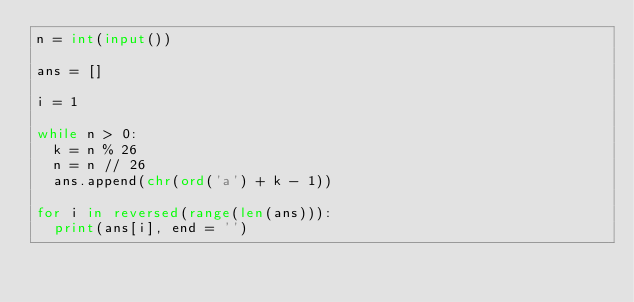Convert code to text. <code><loc_0><loc_0><loc_500><loc_500><_Python_>n = int(input())

ans = []

i = 1

while n > 0:
  k = n % 26
  n = n // 26
  ans.append(chr(ord('a') + k - 1))

for i in reversed(range(len(ans))):
  print(ans[i], end = '')</code> 